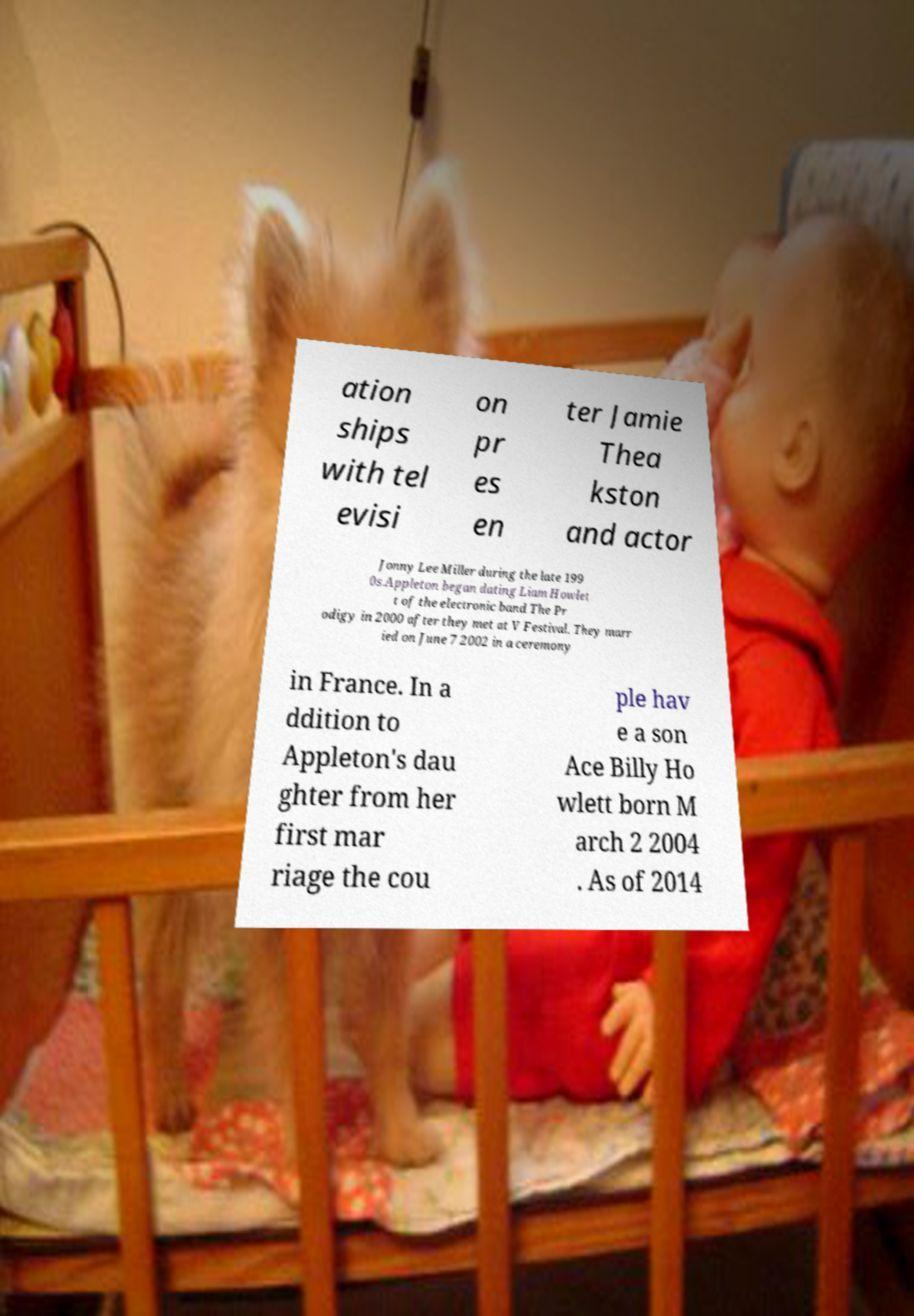Could you extract and type out the text from this image? ation ships with tel evisi on pr es en ter Jamie Thea kston and actor Jonny Lee Miller during the late 199 0s.Appleton began dating Liam Howlet t of the electronic band The Pr odigy in 2000 after they met at V Festival. They marr ied on June 7 2002 in a ceremony in France. In a ddition to Appleton's dau ghter from her first mar riage the cou ple hav e a son Ace Billy Ho wlett born M arch 2 2004 . As of 2014 